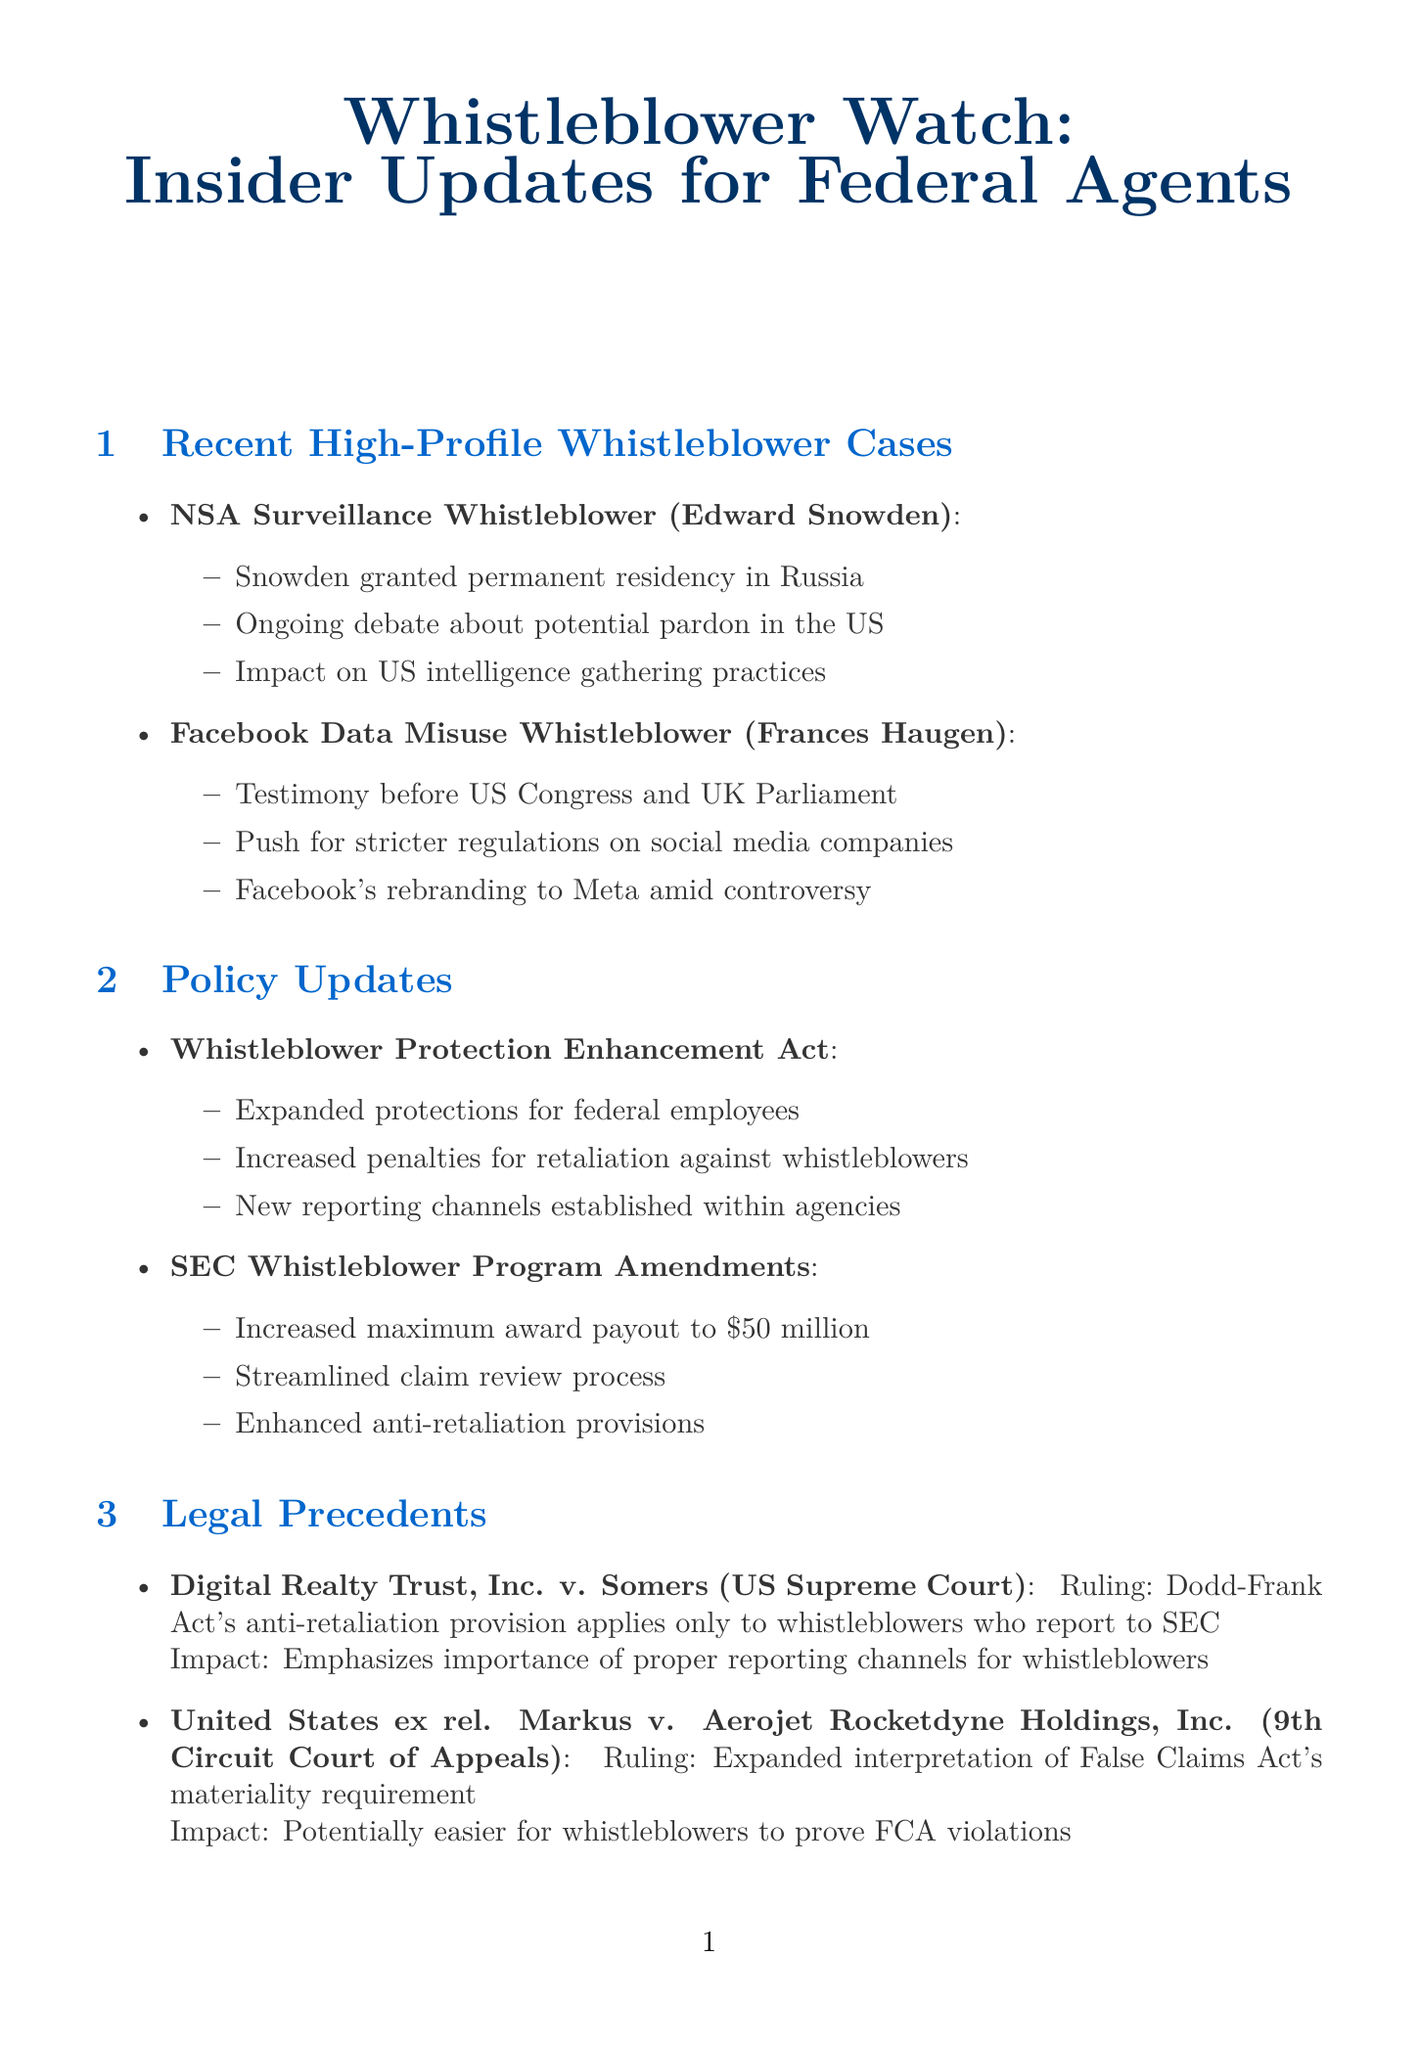What is the title of the newsletter? The title of the newsletter is specifically mentioned at the beginning of the document.
Answer: Whistleblower Watch: Insider Updates for Federal Agents Who is the whistleblower for the Facebook Data Misuse case? The whistleblower's name for the case is listed under Recent High-Profile Whistleblower Cases.
Answer: Frances Haugen What is one of the key developments for Edward Snowden? This information is found in the section discussing recent high-profile whistleblower cases, detailing key developments.
Answer: Snowden granted permanent residency in Russia What is the maximum award payout for the SEC Whistleblower Program after amendments? This figure is referenced in the Policy Updates section regarding amendments to the SEC Whistleblower Program.
Answer: 50 million Which agencies are participating in the Whistleblower Ombudsman Program? The participating agencies are listed in the Interagency Cooperation section of the document.
Answer: DOJ, FBI, CIA, DHS What is the impact of the Digital Realty Trust, Inc. v. Somers ruling? The document specifies the impact of this legal precedent under the Legal Precedents section.
Answer: Emphasizes importance of proper reporting channels for whistleblowers How many techniques are outlined in the Investigation Techniques section? This information can be obtained by counting the items listed in the respective section.
Answer: 2 What new channels were established in the Whistleblower Protection Enhancement Act? The details are found in the Policy Updates section, specifically under the Whistleblower Protection Enhancement Act.
Answer: New reporting channels established within agencies 